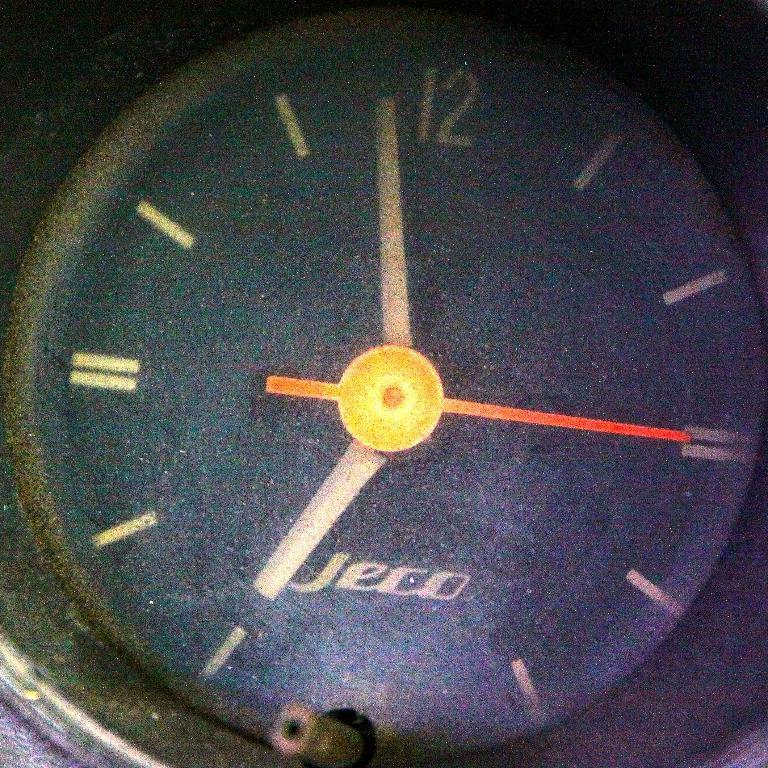What is the main object in the center of the image? There is a clock in the center of the image. What features does the clock have? The clock has hands and text on its face. Are there any numbers on the clock? Yes, there is at least one number on the face of the clock. What type of pie is being served on the clock in the image? There is no pie present in the image; it features a clock with hands, text, and a number on its face. 